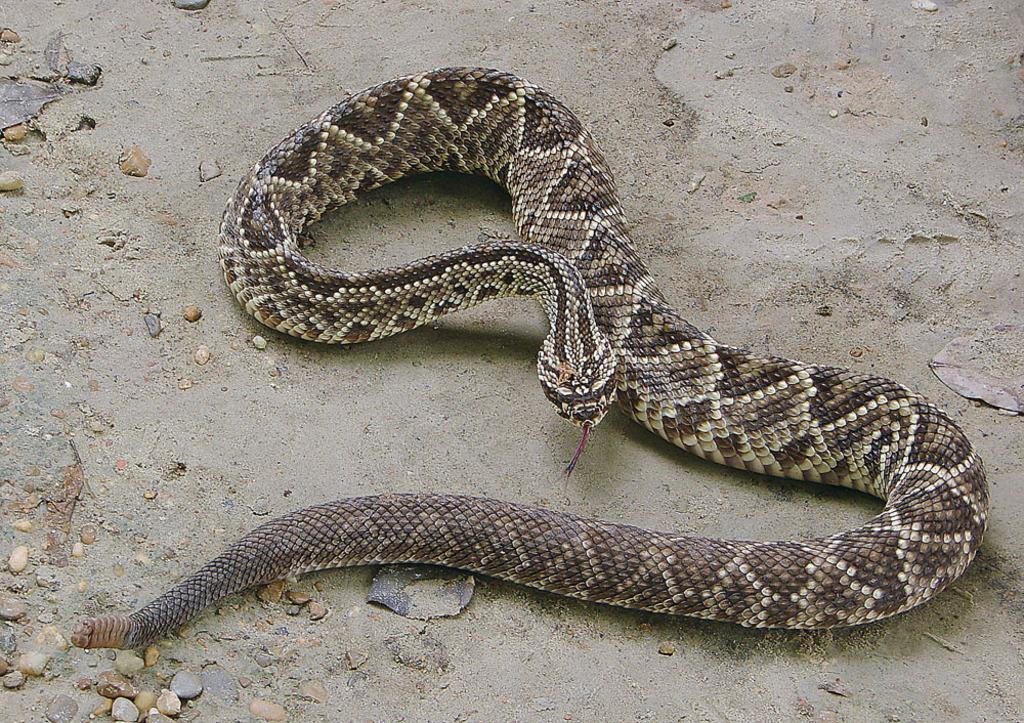What type of animal is in the image? There is a snake in the image. Can you describe the colors of the snake? The snake has black, ash, and white colors. How does the snake interact with the ball in the image? There is no ball present in the image, so the snake cannot interact with it. 